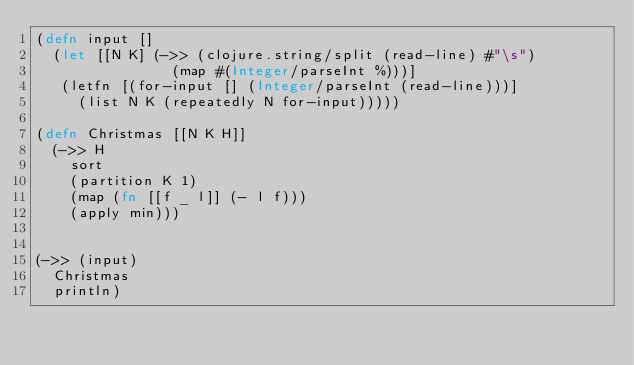Convert code to text. <code><loc_0><loc_0><loc_500><loc_500><_Clojure_>(defn input []
  (let [[N K] (->> (clojure.string/split (read-line) #"\s")
                (map #(Integer/parseInt %)))]
   (letfn [(for-input [] (Integer/parseInt (read-line)))]
     (list N K (repeatedly N for-input)))))

(defn Christmas [[N K H]]
  (->> H
    sort
    (partition K 1)
    (map (fn [[f _ l]] (- l f)))
    (apply min)))


(->> (input)
  Christmas
  println)</code> 